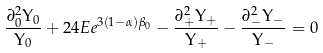<formula> <loc_0><loc_0><loc_500><loc_500>\frac { \partial ^ { 2 } _ { 0 } \Upsilon _ { 0 } } { \Upsilon _ { 0 } } + 2 4 E e ^ { 3 ( 1 - \alpha ) \beta _ { 0 } } - \frac { \partial ^ { 2 } _ { + } \Upsilon _ { + } } { \Upsilon _ { + } } - \frac { \partial ^ { 2 } _ { - } \Upsilon _ { - } } { \Upsilon _ { - } } = 0</formula> 